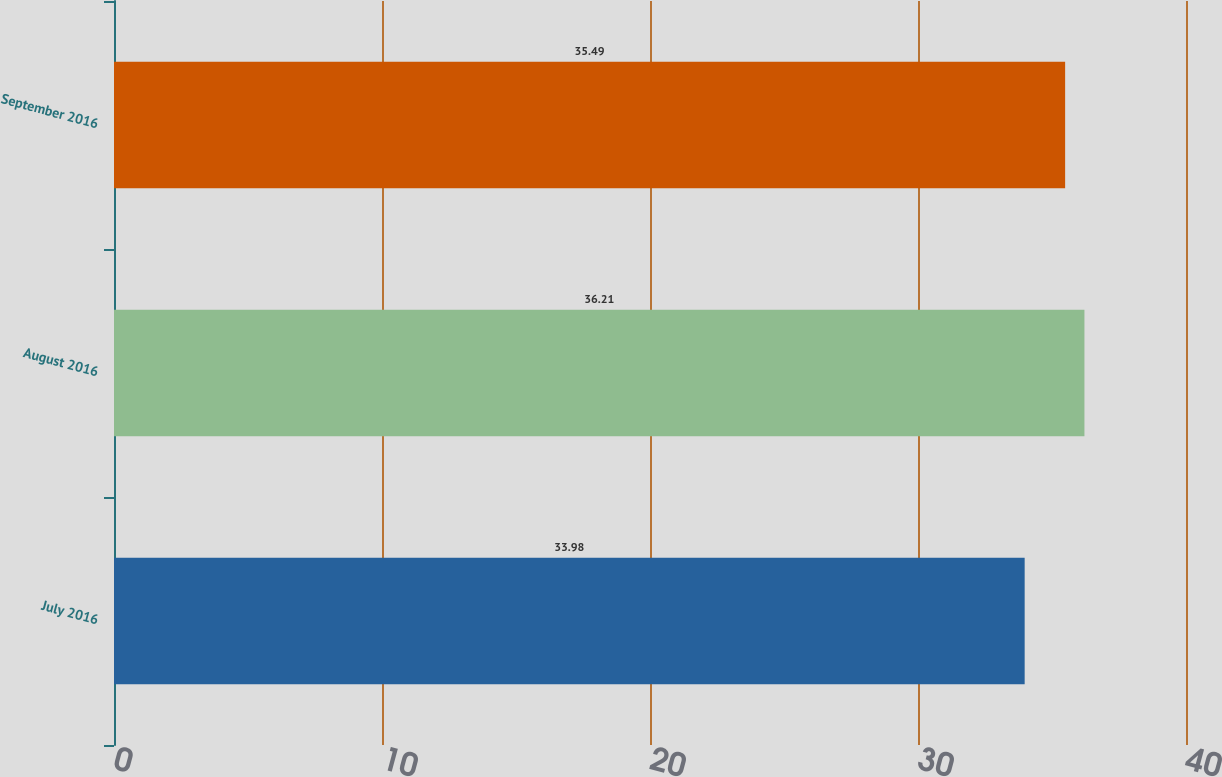Convert chart to OTSL. <chart><loc_0><loc_0><loc_500><loc_500><bar_chart><fcel>July 2016<fcel>August 2016<fcel>September 2016<nl><fcel>33.98<fcel>36.21<fcel>35.49<nl></chart> 